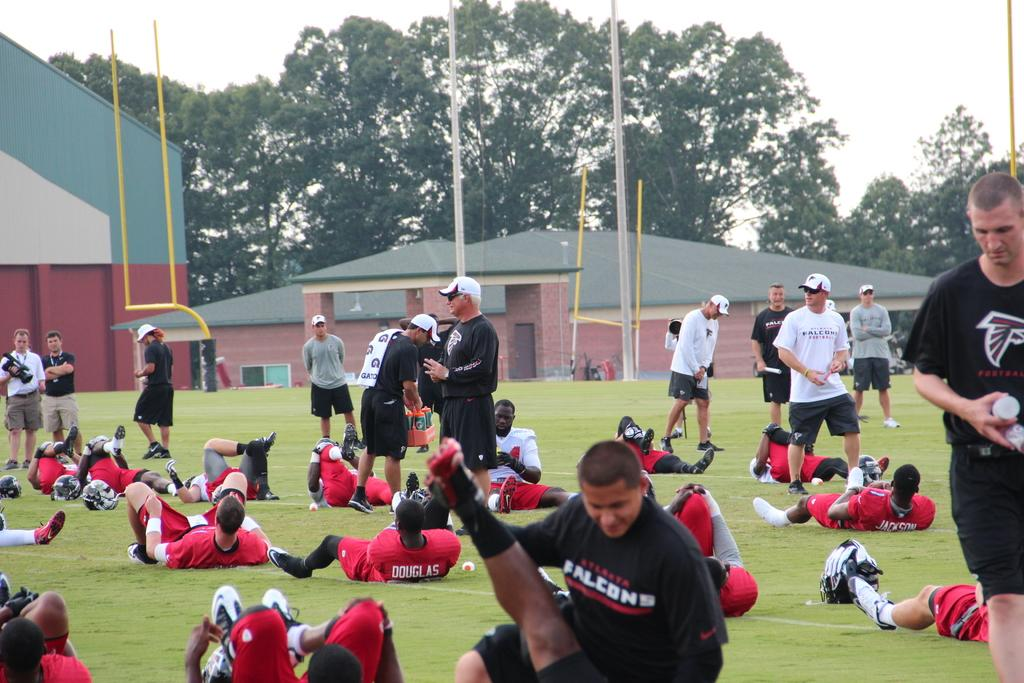<image>
Offer a succinct explanation of the picture presented. Members of the Atlanta Falcons team are working out of a field. 